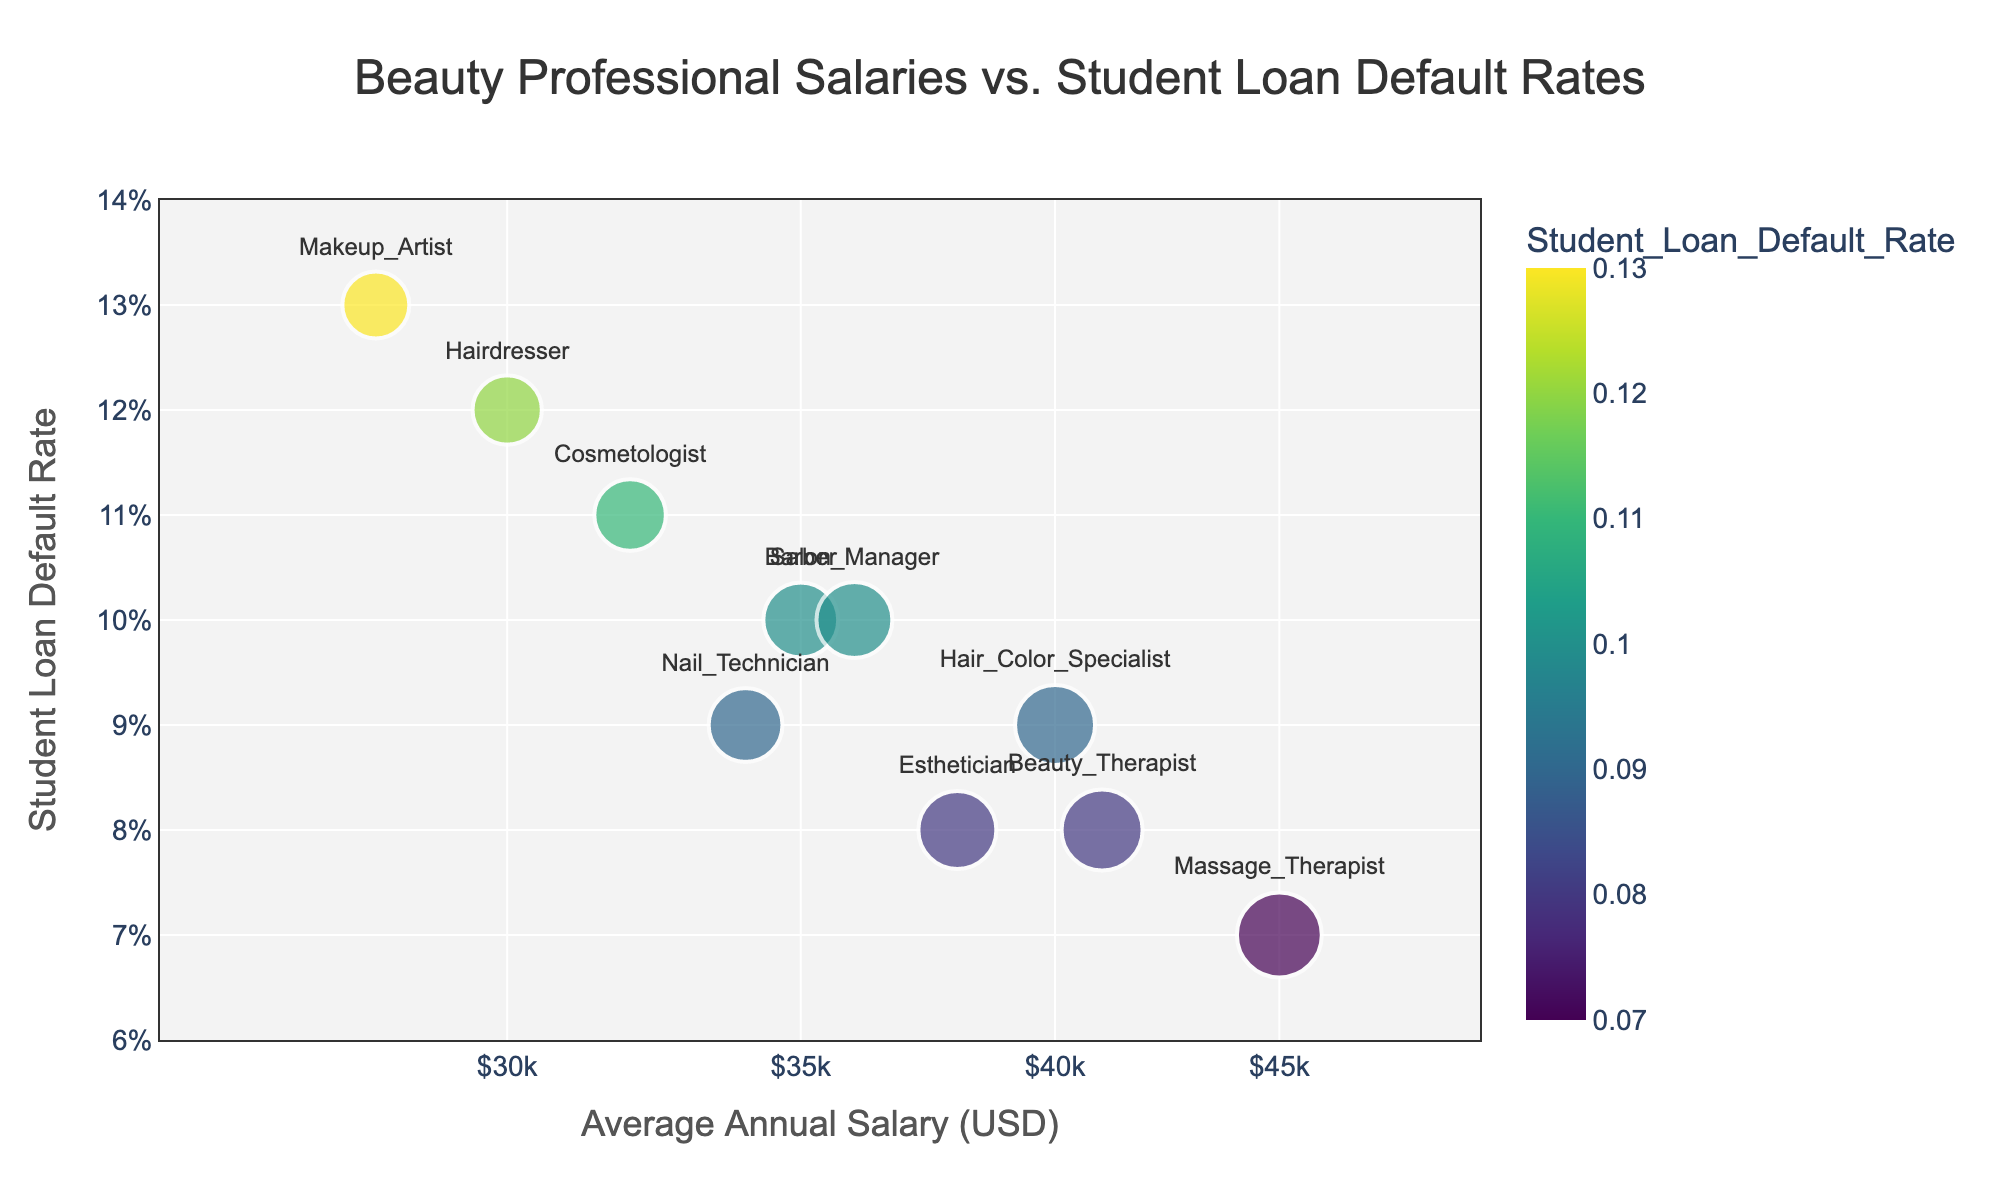What is the title of the scatter plot? The title of the scatter plot is displayed at the top center of the figure with larger font size for visibility. It reads "Beauty Professional Salaries vs. Student Loan Default Rates".
Answer: Beauty Professional Salaries vs. Student Loan Default Rates How many beauty professional categories are shown in the scatter plot? You can count the number of distinct data points, each of which corresponds to a different beauty professional. There are 10 unique data points, thus there are 10 different beauty professional categories.
Answer: 10 What is the annual salary range shown on the x-axis? The x-axis, which is on a logarithmic scale, ranges approximately from $30,000 to $45,000. This is derived from the tick values and text visible on the x-axis.
Answer: $30,000 to $45,000 Which beauty professional has the highest average annual salary? By observing the position of the data points along the x-axis, the beauty professional with the highest average annual salary is the one farthest to the right. The Massage Therapist has an average annual salary of $45,000.
Answer: Massage Therapist Which beauty professional has the lowest student loan default rate? By checking the position of the data points along the y-axis, the professional with the lowest student loan default rate appears closest to the bottom of the plot. The Massage Therapist has the lowest default rate of 0.07.
Answer: Massage Therapist What is the relationship between average annual salaries and student loan default rates for beauty professionals? Observing the general trend in the scatter plot, there is a negative correlation. As the average annual salary increases, the student loan default rate tends to decrease.
Answer: Negative correlation Which beauty professional has an average annual salary of $38,000 and what is their loan default rate? The data point corresponding to an average annual salary of $38,000 represents the Esthetician. The hover data specifies that the Esthetician has a loan default rate of 0.08.
Answer: Esthetician with a default rate of 0.08 How does the student loan default rate for Beauty Therapists compare to that of Hair Color Specialists? To compare, locate the Beauty Therapist and Hair Color Specialist in the plot. The y-axis positions show that Beauty Therapists have a lower default rate (0.08) compared to Hair Color Specialists (0.09).
Answer: Beauty Therapist has a lower default rate What is the average student loan default rate among all the beauty professionals shown in the plot? Add up all the default rates and divide by the number of professionals to find the mean. The sum is 0.12 + 0.11 + 0.13 + 0.10 + 0.09 + 0.08 + 0.07 + 0.09 + 0.10 + 0.08 = 0.97. Divide by 10 (number of professionals): 0.97 / 10 = 0.097.
Answer: 0.097 What can you infer about the placement of data points and the use of logarithmic scale on x-axis? The logarithmic scale on the x-axis is used to accommodate a wide range of salary values, allowing for a more readable distribution of data points. This reveals fine variations in salaries among beauty professionals. Higher salaries are spaced further to the right, making the relationship with default rates clearer.
Answer: Logarithmic scale improves readability and reveals finer variations in data 